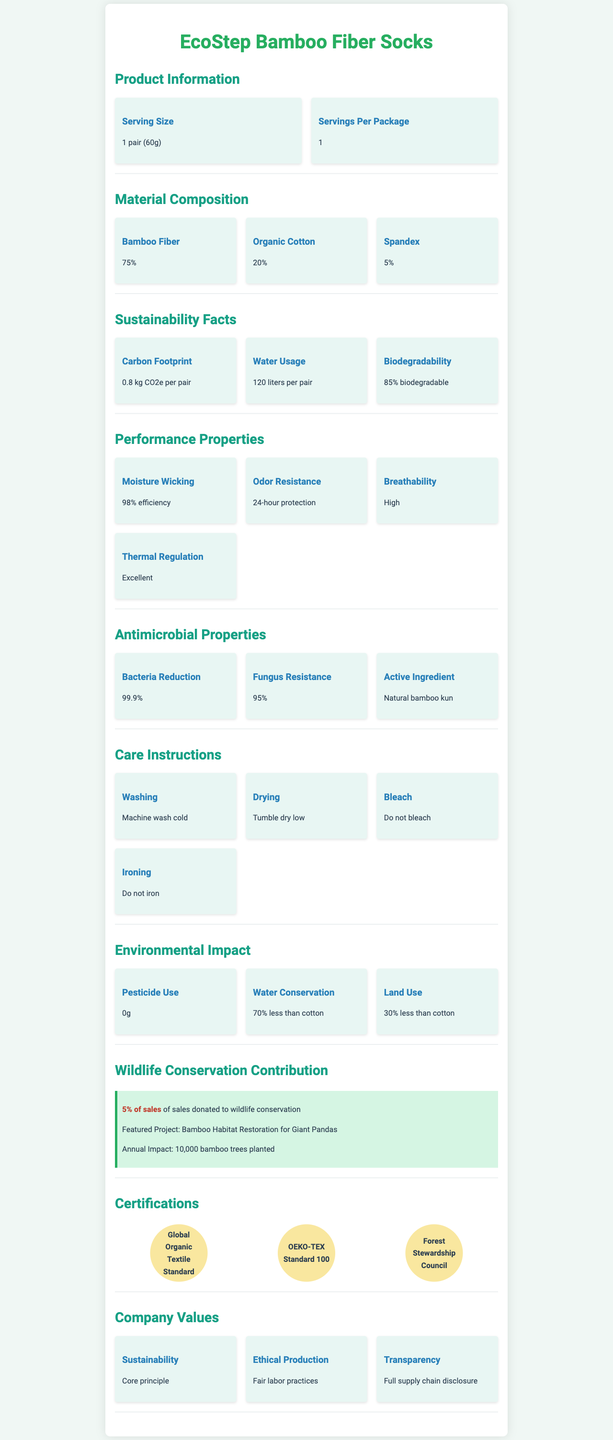What is the serving size of the EcoStep Bamboo Fiber Socks? The serving size is explicitly mentioned in the Product Information section of the document as "1 pair (60g)".
Answer: 1 pair (60g) What percentage of the socks is made of organic cotton? The Material Composition section lists Organic Cotton as comprising 20% of the socks.
Answer: 20% How much water is used per pair of bamboo fiber socks? The Sustainability Facts section states that water usage per pair is 120 liters.
Answer: 120 liters What active ingredient provides antimicrobial properties to the socks? The Antimicrobial Properties section lists Natural bamboo kun as the active ingredient for antimicrobial properties.
Answer: Natural bamboo kun What is the donation percentage of sales to wildlife conservation? The Wildlife Conservation Contribution section mentions that 5% of sales are donated to wildlife conservation.
Answer: 5% of sales Which certification ensures the use of certified bamboo sources? A. Global Organic Textile Standard B. OEKO-TEX Standard 100 C. Forest Stewardship Council The Certifications section lists Forest Stewardship Council as ensuring a certified bamboo source.
Answer: C. Forest Stewardship Council Which of the following is NOT a performance property of the bamboo fiber socks? A. Moisture Wicking B. Flame Resistance C. Breathability D. Thermal Regulation The Performance Properties section lists Moisture Wicking, Breathability, and Thermal Regulation, but does not mention Flame Resistance.
Answer: B. Flame Resistance Are the EcoStep Bamboo Fiber Socks biodegradable? The Sustainability Facts section states that the socks are 85% biodegradable.
Answer: Yes Provide a summary of the EcoStep Bamboo Fiber Socks document. This summary captures all the main sections and key points about the product, including its composition, performance, sustainability, contributions to wildlife conservation, and certifications.
Answer: The EcoStep Bamboo Fiber Socks document provides detailed information about the product, including its material composition (75% bamboo fiber, 20% organic cotton, 5% spandex), sustainability facts (e.g., 0.8 kg CO2e carbon footprint per pair, 120 liters water usage per pair), and performance properties (e.g., 98% moisture-wicking efficiency, 99.9% bacteria reduction). It also highlights the company's commitment to wildlife conservation by donating 5% of sales, and lists various certifications such as Global Organic Textile Standard, OEKO-TEX Standard 100, and Forest Stewardship Council. Care instructions and environmental impact details are also provided. What is the exact annual impact of the company's conservation contribution? The Wildlife Conservation Contribution section states an annual impact of planting 10,000 bamboo trees.
Answer: 10,000 bamboo trees planted Can you determine how much pesticides are used in the production of EcoStep Bamboo Fiber Socks? The Environmental Impact section clearly states that pesticide use is 0g.
Answer: 0g What is the purpose of the featured project in the Wildlife Conservation Contribution section? The featured project focuses on Bamboo Habitat Restoration for Giant Pandas, as stated in the Wildlife Conservation Contribution section.
Answer: Bamboo Habitat Restoration for Giant Pandas What type of washing method is recommended for the socks? A. Hand wash B. Machine wash cold C. Machine wash hot D. Dry clean The Care Instructions section advises to "Machine wash cold".
Answer: B. Machine wash cold What is the thermal regulation property rating for the socks? The Performance Properties section rates the thermal regulation of the socks as Excellent.
Answer: Excellent What percentage of the fabric is composed of spandex? The Material Composition section lists Spandex as making up 5% of the socks.
Answer: 5% What is the savings in water usage when comparing bamboo to cotton? The Environmental Impact section notes that bamboo fiber uses 70% less water than cotton.
Answer: 70% less than cotton Could you find any information about the company's revenue from the document? The document does not provide any details about the company's revenue.
Answer: Not enough information What is the bacteria reduction efficiency of the socks? The Antimicrobial Properties section states the bacteria reduction efficiency as 99.9%.
Answer: 99.9% 